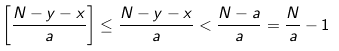Convert formula to latex. <formula><loc_0><loc_0><loc_500><loc_500>\left [ \frac { N - y - x } { a } \right ] \leq \frac { N - y - x } { a } < \frac { N - a } { a } = \frac { N } { a } - 1</formula> 